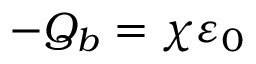<formula> <loc_0><loc_0><loc_500><loc_500>- Q _ { b } = \chi \varepsilon _ { 0 }</formula> 